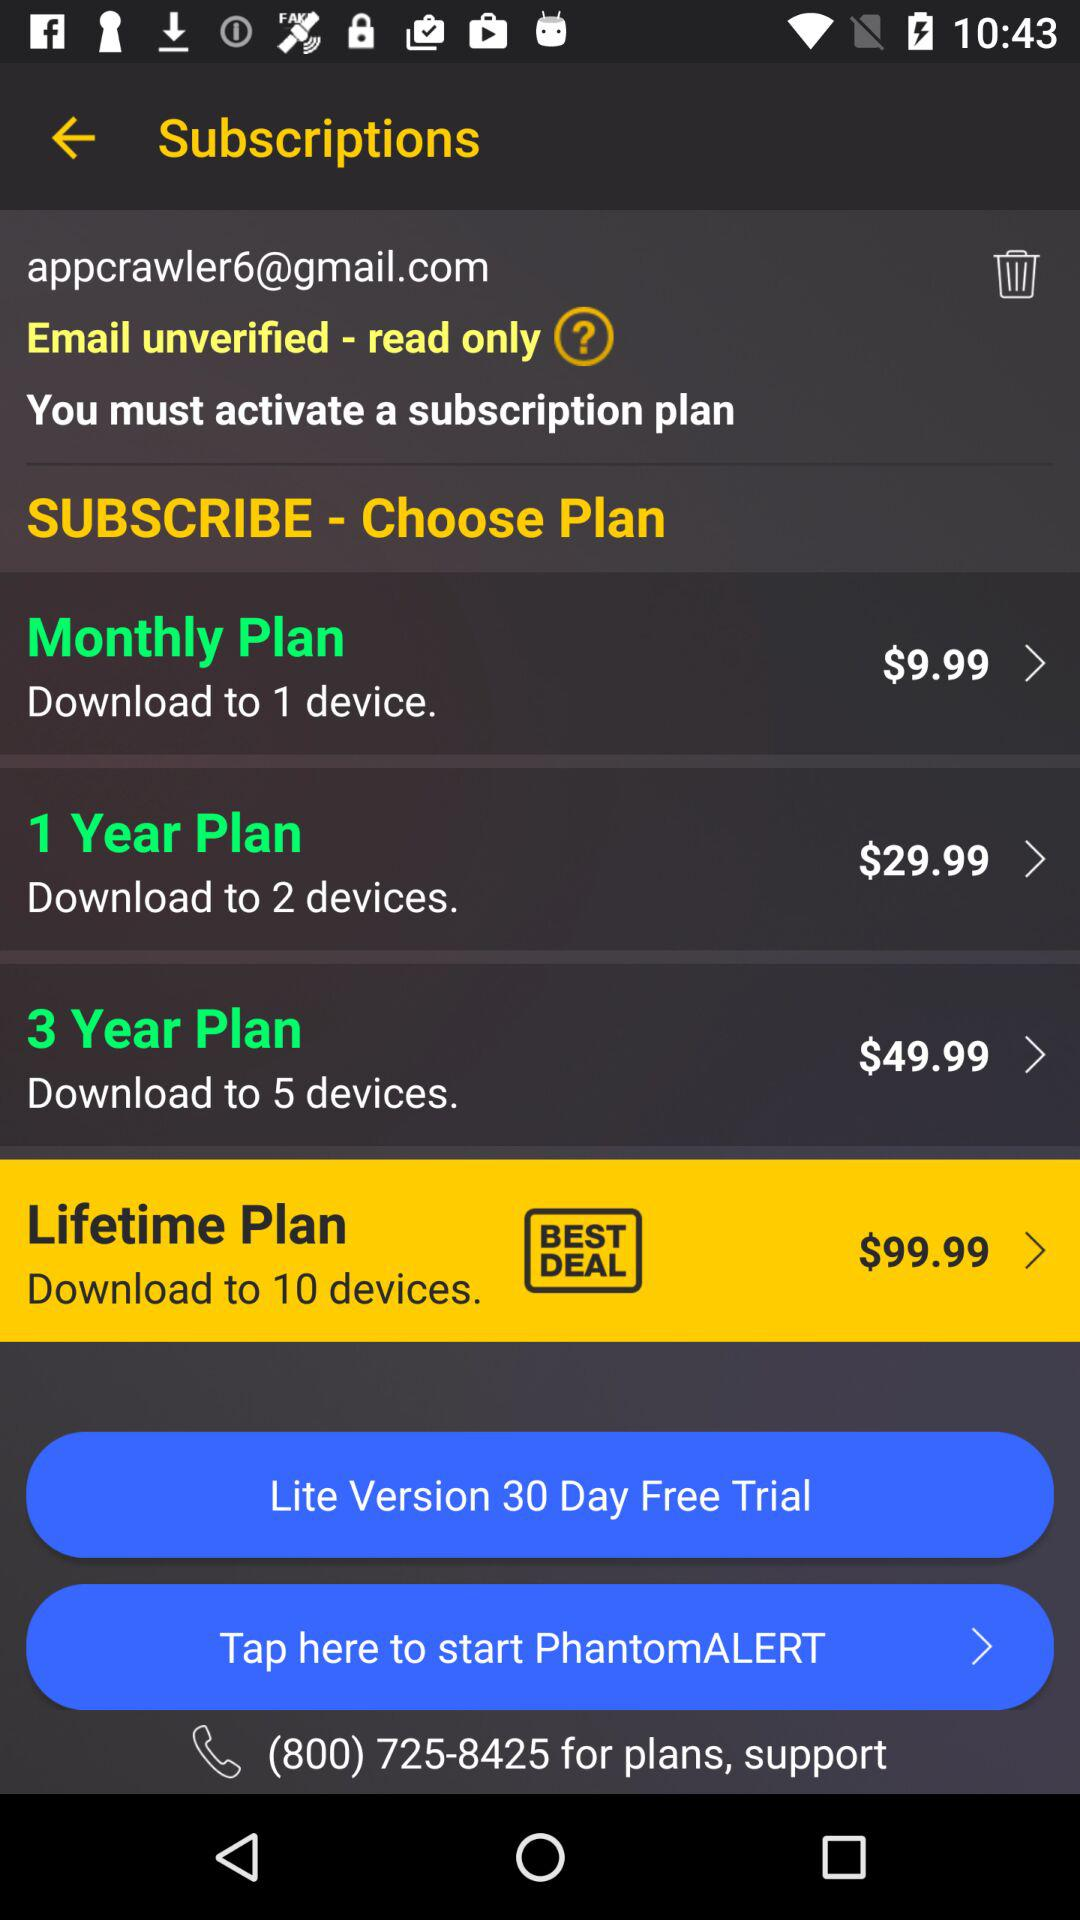What is the price of the "3 Year Plan"? The price of the "3 Year Plan" is $49.99. 